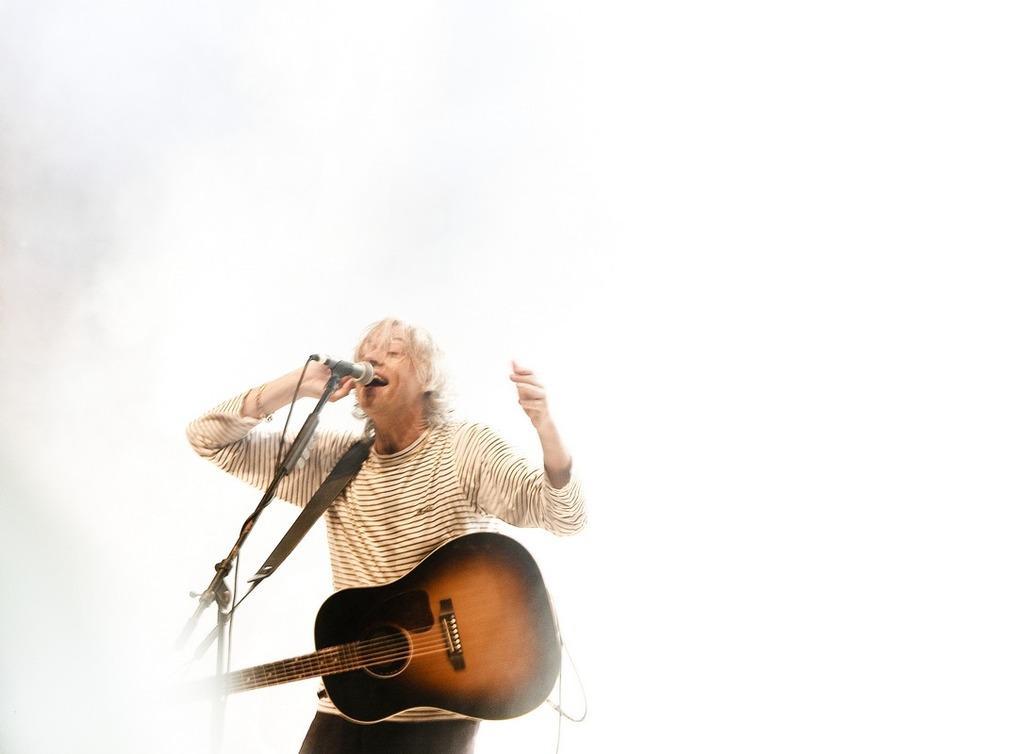Can you describe this image briefly? In the picture there is a man who is singing a song he is also holding the guitar the background there is a white color wall. 